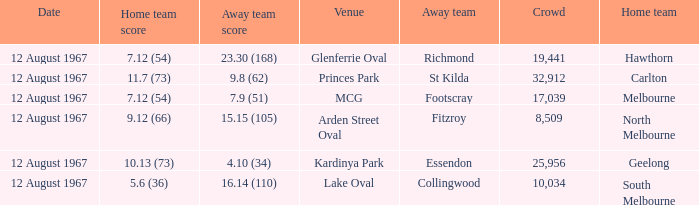What is the date of the game between Melbourne and Footscray? 12 August 1967. Can you parse all the data within this table? {'header': ['Date', 'Home team score', 'Away team score', 'Venue', 'Away team', 'Crowd', 'Home team'], 'rows': [['12 August 1967', '7.12 (54)', '23.30 (168)', 'Glenferrie Oval', 'Richmond', '19,441', 'Hawthorn'], ['12 August 1967', '11.7 (73)', '9.8 (62)', 'Princes Park', 'St Kilda', '32,912', 'Carlton'], ['12 August 1967', '7.12 (54)', '7.9 (51)', 'MCG', 'Footscray', '17,039', 'Melbourne'], ['12 August 1967', '9.12 (66)', '15.15 (105)', 'Arden Street Oval', 'Fitzroy', '8,509', 'North Melbourne'], ['12 August 1967', '10.13 (73)', '4.10 (34)', 'Kardinya Park', 'Essendon', '25,956', 'Geelong'], ['12 August 1967', '5.6 (36)', '16.14 (110)', 'Lake Oval', 'Collingwood', '10,034', 'South Melbourne']]} 